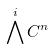<formula> <loc_0><loc_0><loc_500><loc_500>\bigwedge ^ { i } C ^ { n }</formula> 